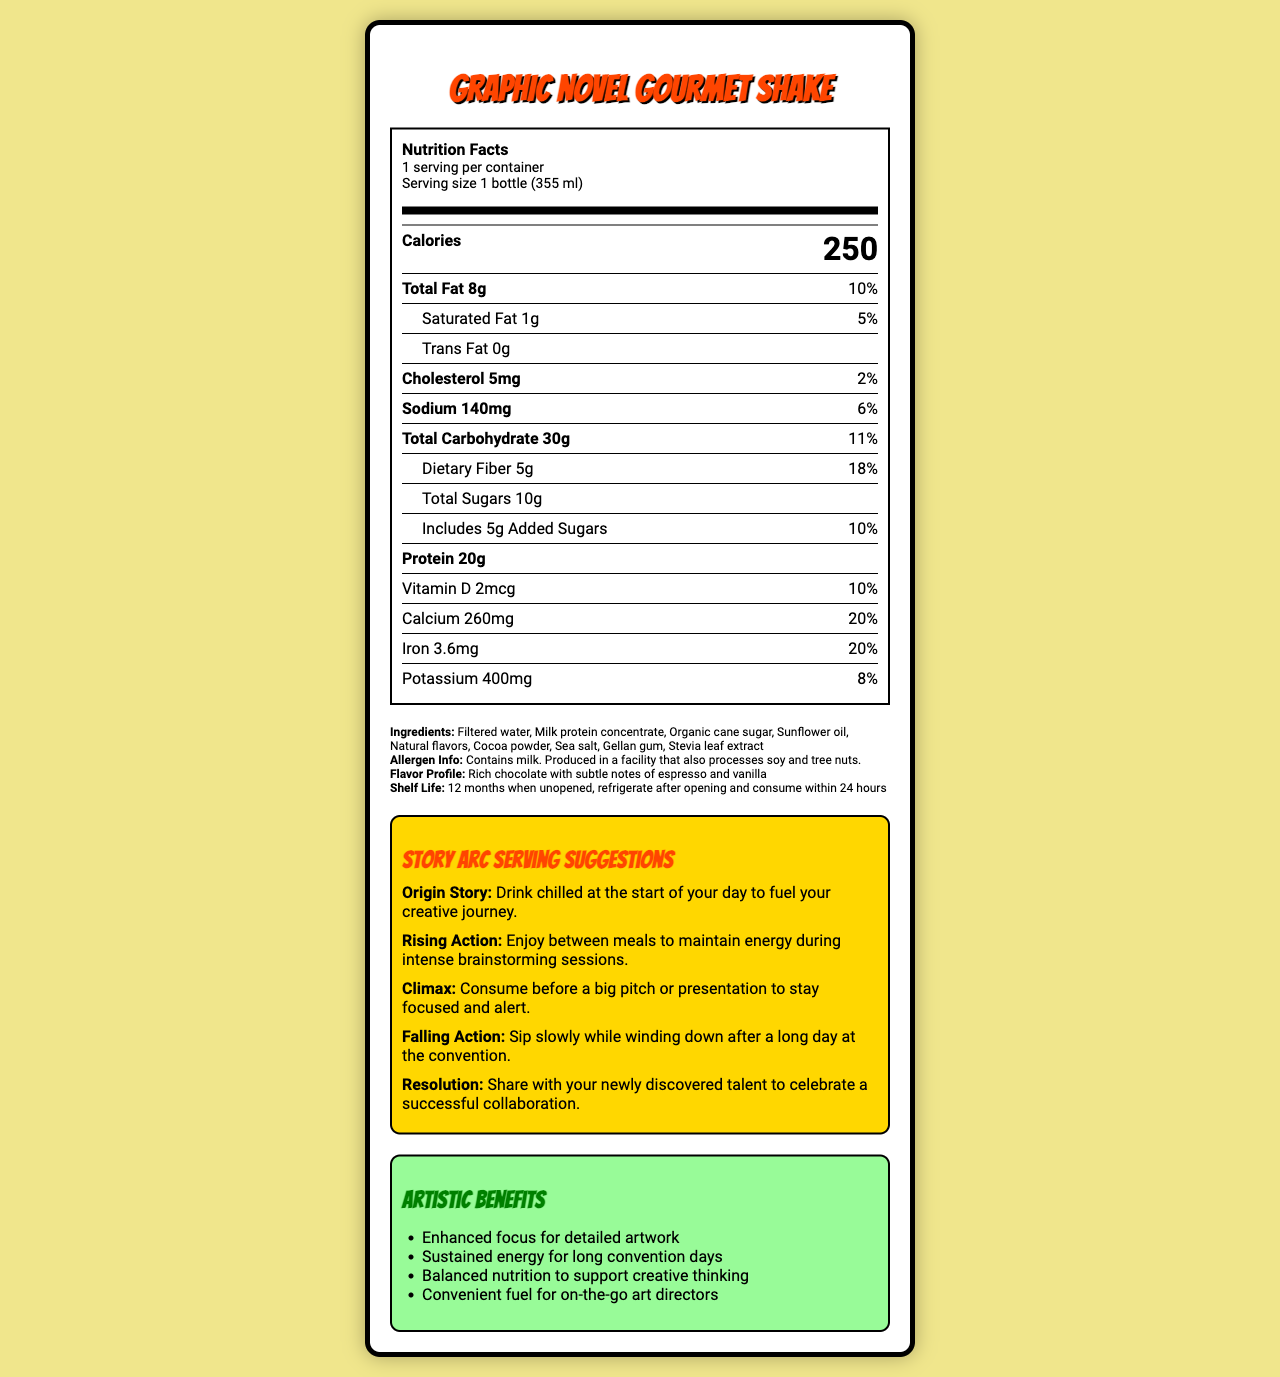what is the product name? The product name is clearly listed at the top of the document.
Answer: Graphic Novel Gourmet Shake how many servings are in one container? The document states that there is 1 serving per container.
Answer: 1 what is the serving size? The serving size is specified as "1 bottle (355 ml)".
Answer: 1 bottle (355 ml) how many calories are in one serving? The calorie content per serving is shown in large, bold text as 250.
Answer: 250 how much protein is in the shake? The protein content is listed as 20g in the nutrient section.
Answer: 20g which of the following is NOT an artistic benefit of the shake? A. Enhanced focus for detailed artwork B. Increased muscle mass C. Sustained energy for long convention days D. Balanced nutrition to support creative thinking The listed artistic benefits do not include increased muscle mass.
Answer: B what is the flavor profile of the shake? A. Vanilla B. Chocolate C. Strawberry The flavor profile is described as rich chocolate with subtle notes of espresso and vanilla.
Answer: B does the shake contain any trans fat? The document specifies that trans fat is 0g.
Answer: No what are the total carbohydrates in one serving? The total carbohydrates per serving are listed as 30g.
Answer: 30g does the shake contain any dietary fiber? if so, how much? The dietary fiber content is shown as 5g and amounts to 18% of the daily value.
Answer: Yes, 5g when is it suggested to consume the shake for "Rising Action"? The suggestion for the "Rising Action" story arc is to consume the shake between meals to maintain energy during brainstorming sessions.
Answer: Between meals to maintain energy during intense brainstorming sessions what is the allergen info of the shake? The allergen information is clearly stated in the document.
Answer: Contains milk. Produced in a facility that also processes soy and tree nuts. how much added sugars are in the shake, and what’s the daily value percentage for it? The document states there are 5g of added sugars, constituting 10% of the daily value.
Answer: 5g, 10% which of the following vitamins or minerals contributes the highest daily value percentage? A. Vitamin D B. Calcium C. Iron D. Potassium Calcium contributes the highest daily value percentage at 20%.
Answer: B is the shake safe for people with tree nut allergies? The allergen information states that the shake is produced in a facility that processes tree nuts.
Answer: No summarize the main idea of the document. The document aims to combine nutritional facts with creative storytelling to appeal to a target audience of art directors and creatives.
Answer: The document provides detailed nutritional information and unique narrative serving suggestions for the Graphic Novel Gourmet Shake, a meal replacement drink designed with artistic benefits and a rich chocolate flavor. It outlines serving size, calorie content, macronutrients, vitamins, minerals, allergen information, and includes creative consumption suggestions inspired by different story arcs. what is the sugar content of the cocoa powder used in the shake? The document does not provide specific information about the sugar content in the cocoa powder ingredient.
Answer: Cannot be determined 